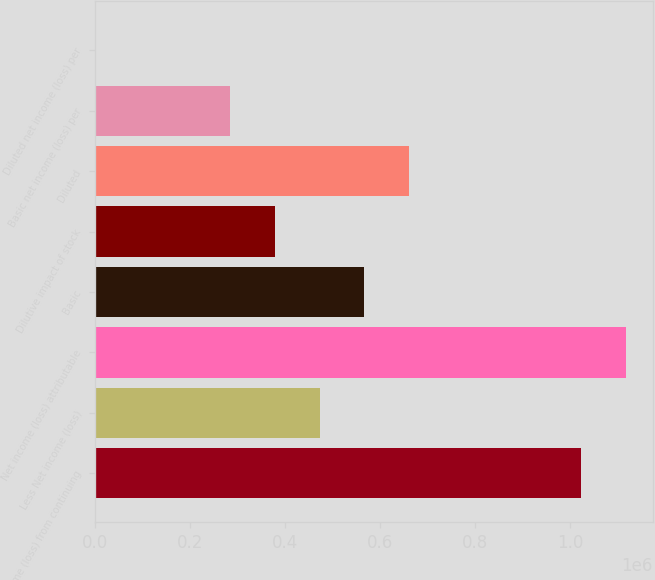Convert chart. <chart><loc_0><loc_0><loc_500><loc_500><bar_chart><fcel>Income (loss) from continuing<fcel>Less Net income (loss)<fcel>Net income (loss) attributable<fcel>Basic<fcel>Dilutive impact of stock<fcel>Diluted<fcel>Basic net income (loss) per<fcel>Diluted net income (loss) per<nl><fcel>1.02337e+06<fcel>472348<fcel>1.11784e+06<fcel>566817<fcel>377878<fcel>661286<fcel>283409<fcel>2.04<nl></chart> 